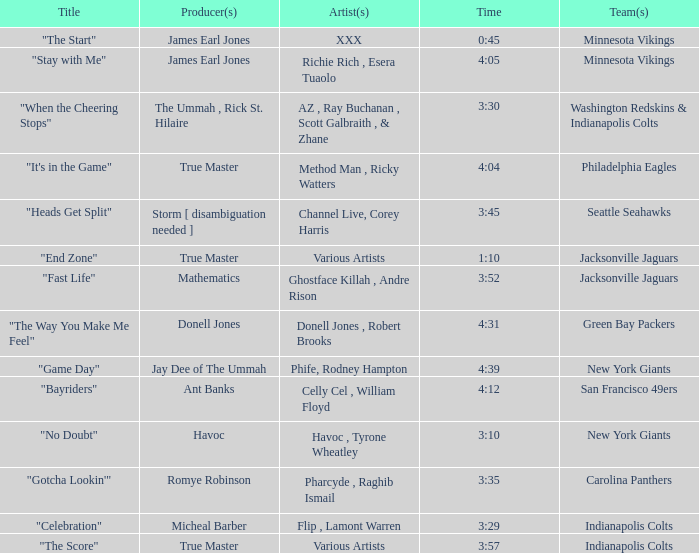Who is the artist of the Seattle Seahawks track? Channel Live, Corey Harris. 